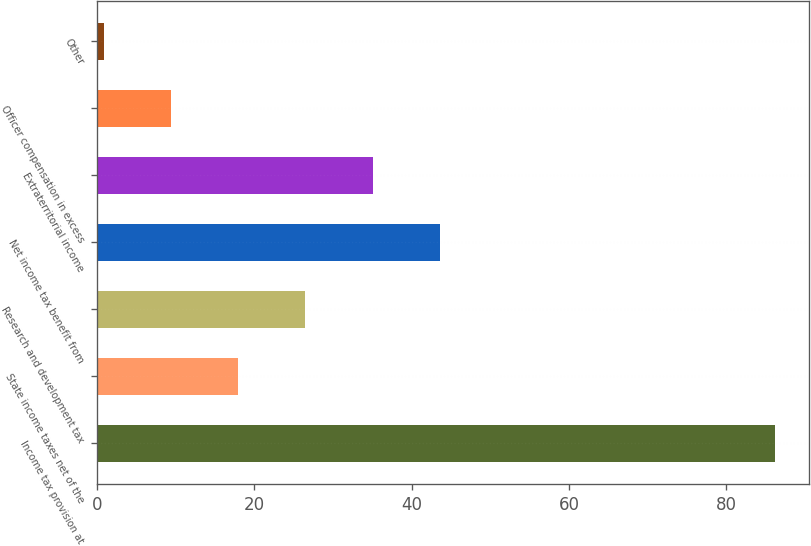Convert chart. <chart><loc_0><loc_0><loc_500><loc_500><bar_chart><fcel>Income tax provision at<fcel>State income taxes net of the<fcel>Research and development tax<fcel>Net income tax benefit from<fcel>Extraterritorial income<fcel>Officer compensation in excess<fcel>Other<nl><fcel>86.2<fcel>17.96<fcel>26.49<fcel>43.55<fcel>35.02<fcel>9.43<fcel>0.9<nl></chart> 